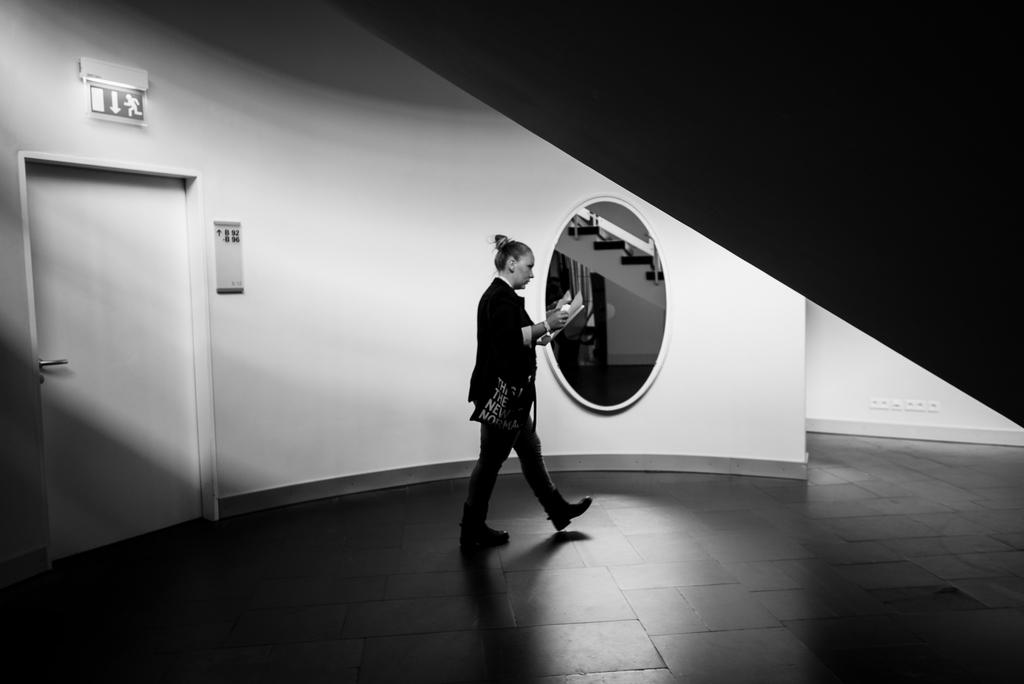Who is present in the image? There is a lady in the image. What is the lady holding? The lady is holding a paper. What is the lady doing in the image? The lady is walking. What can be seen in the background of the image? There is a wall and a door in the background of the image. What is an unusual feature visible through a mirror in the image? Stars are visible through a mirror in the image. What type of pies is the monkey eating in the image? There is no monkey or pies present in the image. How does the jelly interact with the lady in the image? There is no jelly present in the image, so it cannot interact with the lady. 